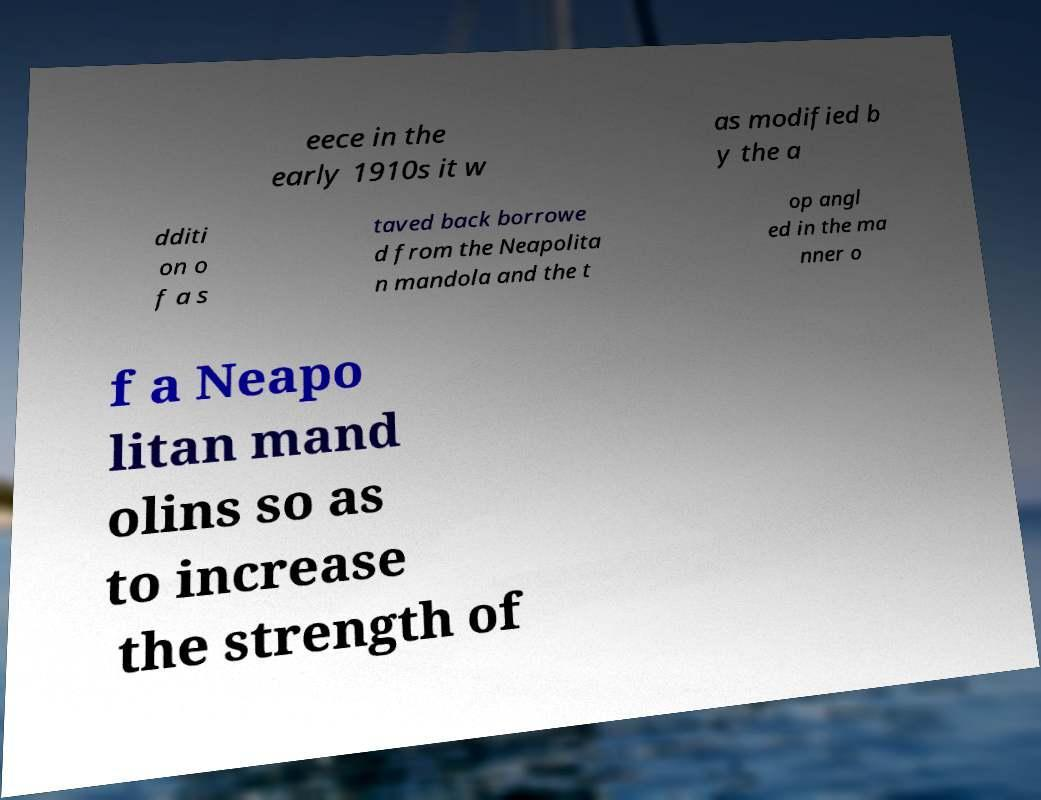Can you accurately transcribe the text from the provided image for me? eece in the early 1910s it w as modified b y the a dditi on o f a s taved back borrowe d from the Neapolita n mandola and the t op angl ed in the ma nner o f a Neapo litan mand olins so as to increase the strength of 